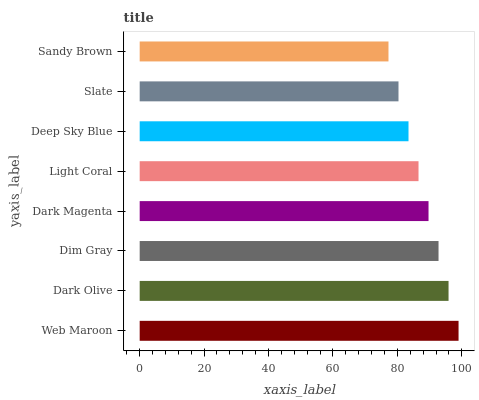Is Sandy Brown the minimum?
Answer yes or no. Yes. Is Web Maroon the maximum?
Answer yes or no. Yes. Is Dark Olive the minimum?
Answer yes or no. No. Is Dark Olive the maximum?
Answer yes or no. No. Is Web Maroon greater than Dark Olive?
Answer yes or no. Yes. Is Dark Olive less than Web Maroon?
Answer yes or no. Yes. Is Dark Olive greater than Web Maroon?
Answer yes or no. No. Is Web Maroon less than Dark Olive?
Answer yes or no. No. Is Dark Magenta the high median?
Answer yes or no. Yes. Is Light Coral the low median?
Answer yes or no. Yes. Is Web Maroon the high median?
Answer yes or no. No. Is Web Maroon the low median?
Answer yes or no. No. 